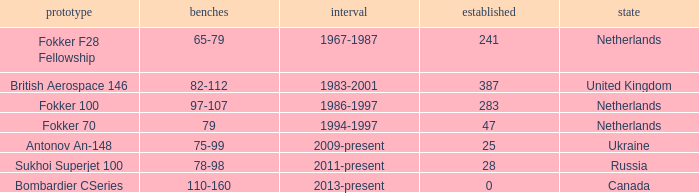Between which years were there 241 fokker 70 model cabins built? 1994-1997. 